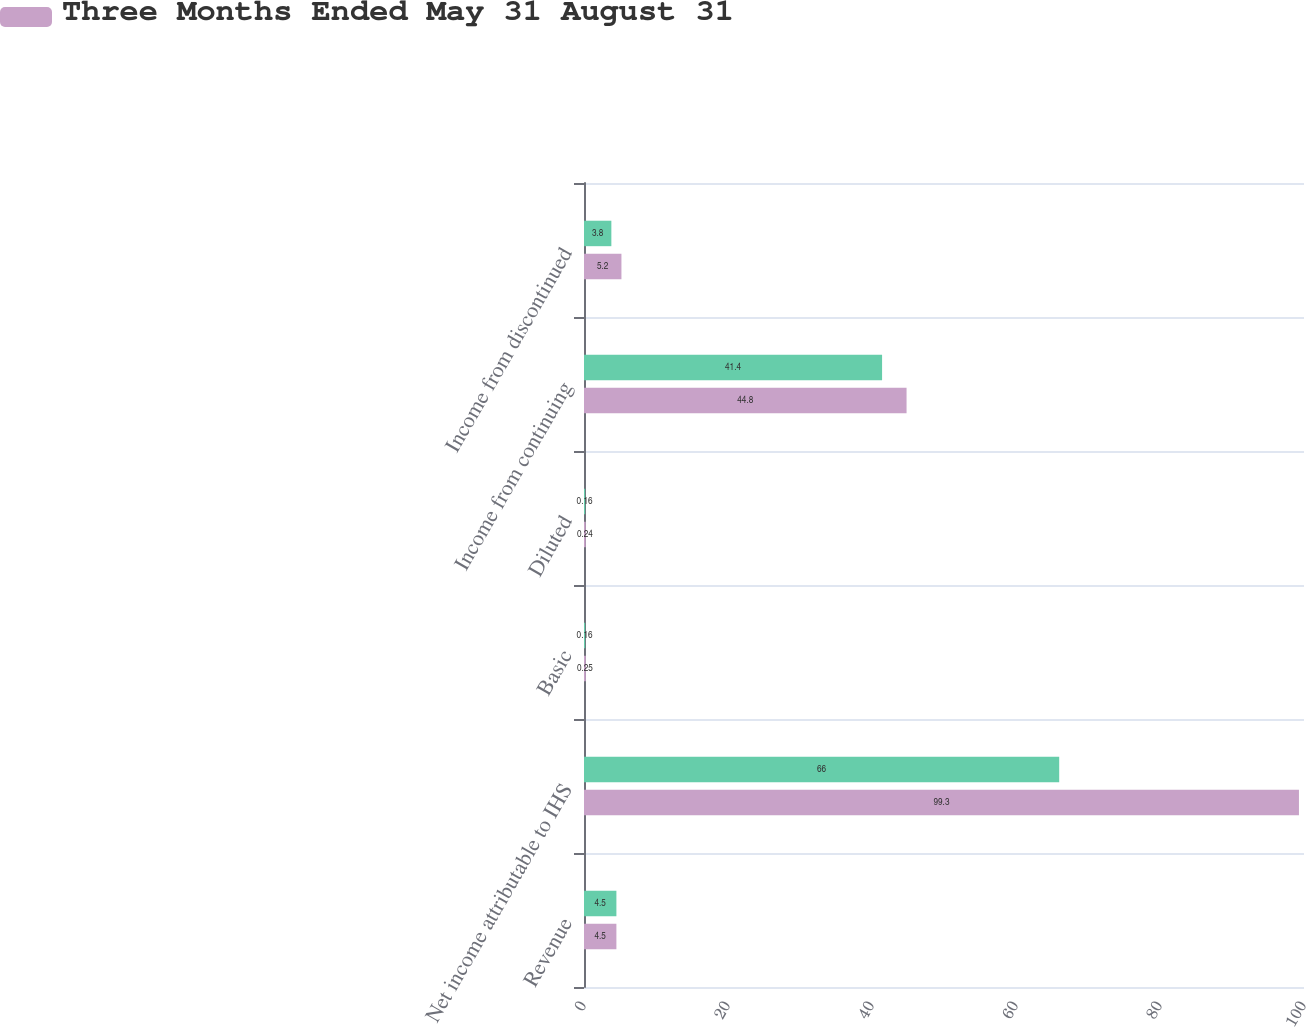<chart> <loc_0><loc_0><loc_500><loc_500><stacked_bar_chart><ecel><fcel>Revenue<fcel>Net income attributable to IHS<fcel>Basic<fcel>Diluted<fcel>Income from continuing<fcel>Income from discontinued<nl><fcel>nan<fcel>4.5<fcel>66<fcel>0.16<fcel>0.16<fcel>41.4<fcel>3.8<nl><fcel>Three Months Ended May 31 August 31<fcel>4.5<fcel>99.3<fcel>0.25<fcel>0.24<fcel>44.8<fcel>5.2<nl></chart> 